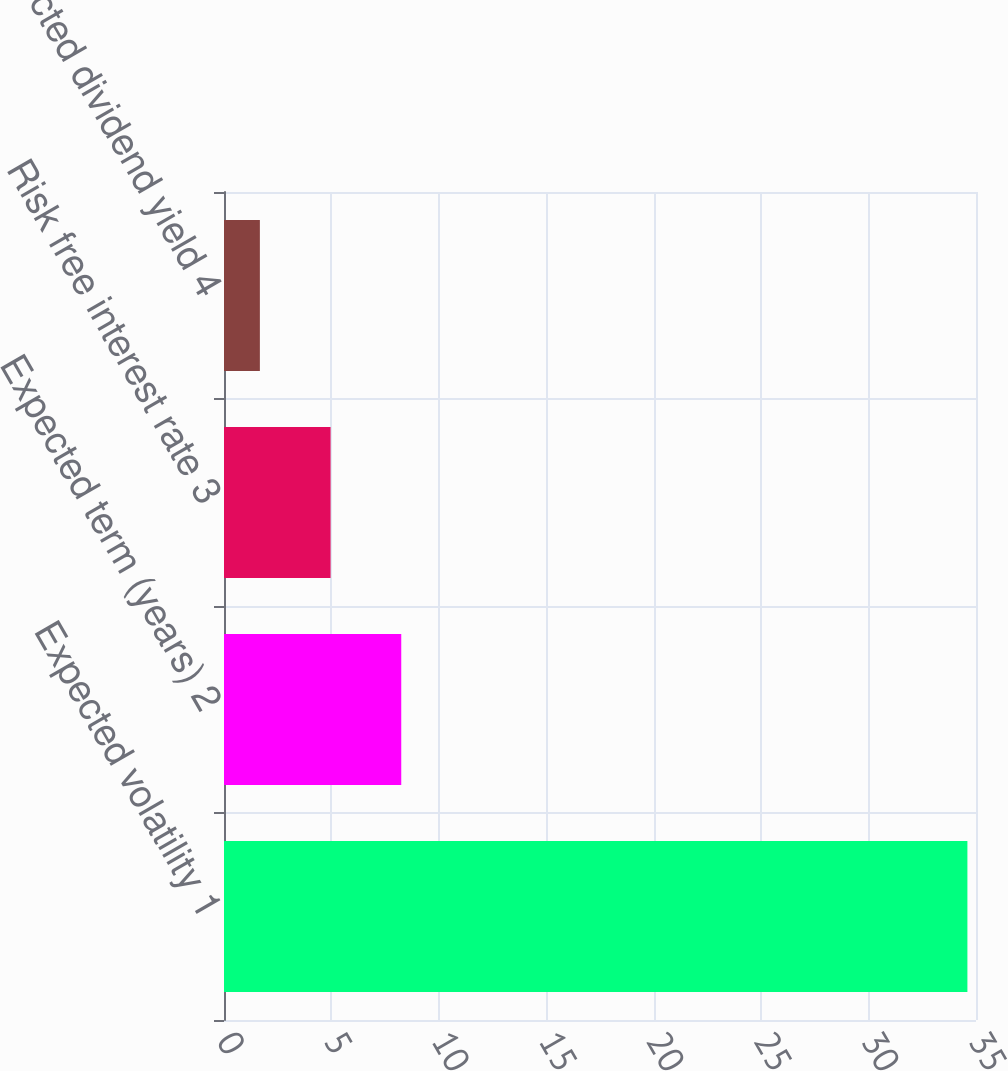Convert chart. <chart><loc_0><loc_0><loc_500><loc_500><bar_chart><fcel>Expected volatility 1<fcel>Expected term (years) 2<fcel>Risk free interest rate 3<fcel>Expected dividend yield 4<nl><fcel>34.6<fcel>8.25<fcel>4.96<fcel>1.67<nl></chart> 